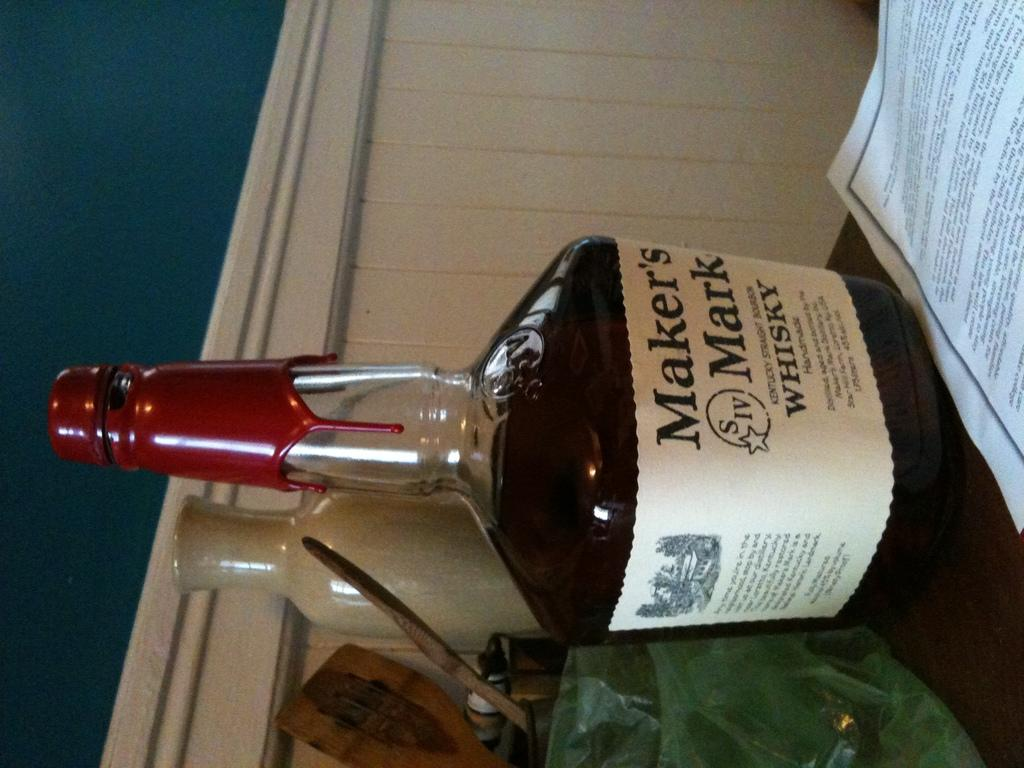<image>
Offer a succinct explanation of the picture presented. A bottle of Maker's Mark whiskey sits next to a piece of paper. 